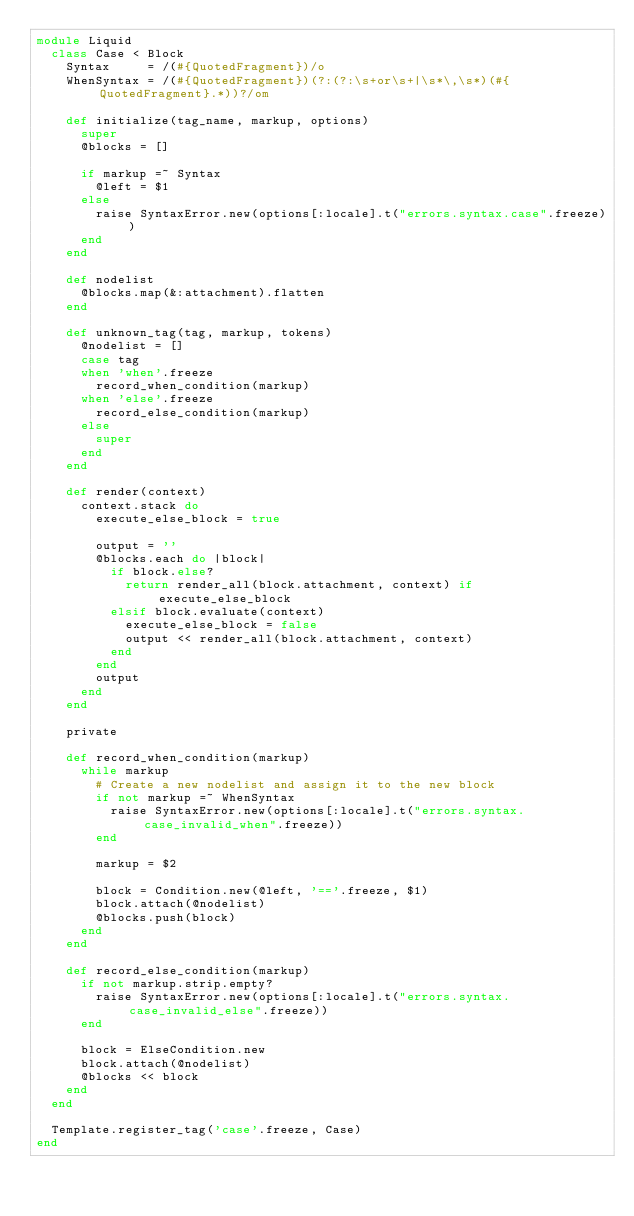<code> <loc_0><loc_0><loc_500><loc_500><_Ruby_>module Liquid
  class Case < Block
    Syntax     = /(#{QuotedFragment})/o
    WhenSyntax = /(#{QuotedFragment})(?:(?:\s+or\s+|\s*\,\s*)(#{QuotedFragment}.*))?/om

    def initialize(tag_name, markup, options)
      super
      @blocks = []

      if markup =~ Syntax
        @left = $1
      else
        raise SyntaxError.new(options[:locale].t("errors.syntax.case".freeze))
      end
    end

    def nodelist
      @blocks.map(&:attachment).flatten
    end

    def unknown_tag(tag, markup, tokens)
      @nodelist = []
      case tag
      when 'when'.freeze
        record_when_condition(markup)
      when 'else'.freeze
        record_else_condition(markup)
      else
        super
      end
    end

    def render(context)
      context.stack do
        execute_else_block = true

        output = ''
        @blocks.each do |block|
          if block.else?
            return render_all(block.attachment, context) if execute_else_block
          elsif block.evaluate(context)
            execute_else_block = false
            output << render_all(block.attachment, context)
          end
        end
        output
      end
    end

    private

    def record_when_condition(markup)
      while markup
        # Create a new nodelist and assign it to the new block
        if not markup =~ WhenSyntax
          raise SyntaxError.new(options[:locale].t("errors.syntax.case_invalid_when".freeze))
        end

        markup = $2

        block = Condition.new(@left, '=='.freeze, $1)
        block.attach(@nodelist)
        @blocks.push(block)
      end
    end

    def record_else_condition(markup)
      if not markup.strip.empty?
        raise SyntaxError.new(options[:locale].t("errors.syntax.case_invalid_else".freeze))
      end

      block = ElseCondition.new
      block.attach(@nodelist)
      @blocks << block
    end
  end

  Template.register_tag('case'.freeze, Case)
end
</code> 